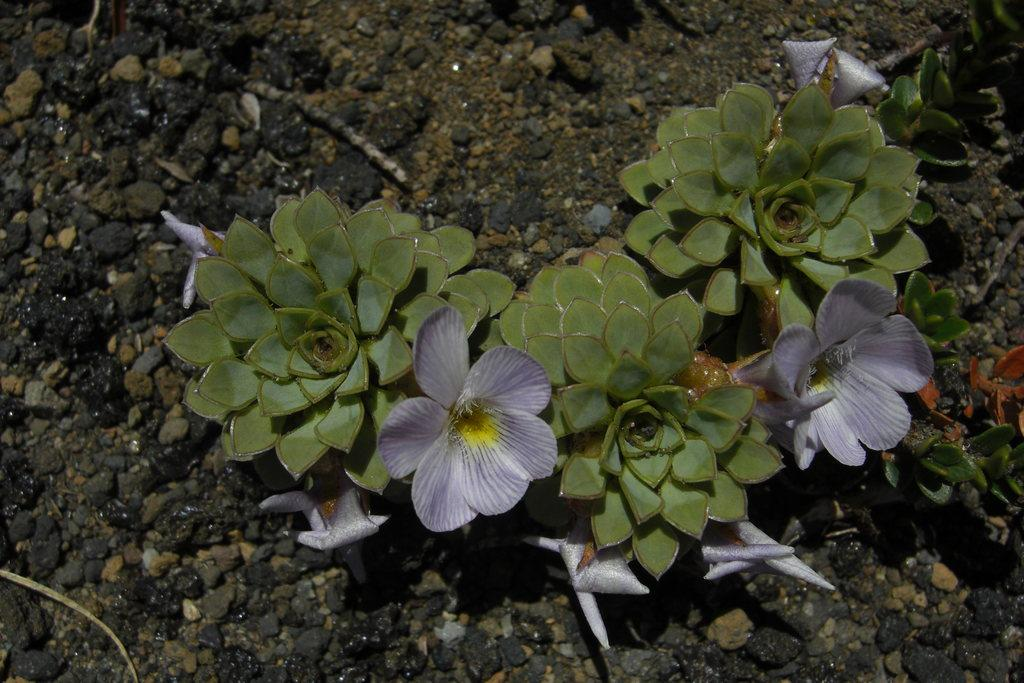What type of plants can be seen in the image? There are plants with flowers in the image. What can be found in the image besides the plants? There is a path in the image. How is the path constructed? The path has stones on it. What type of straw is used to make the sheet in the image? There is no straw or sheet present in the image; it features plants with flowers and a path with stones. 